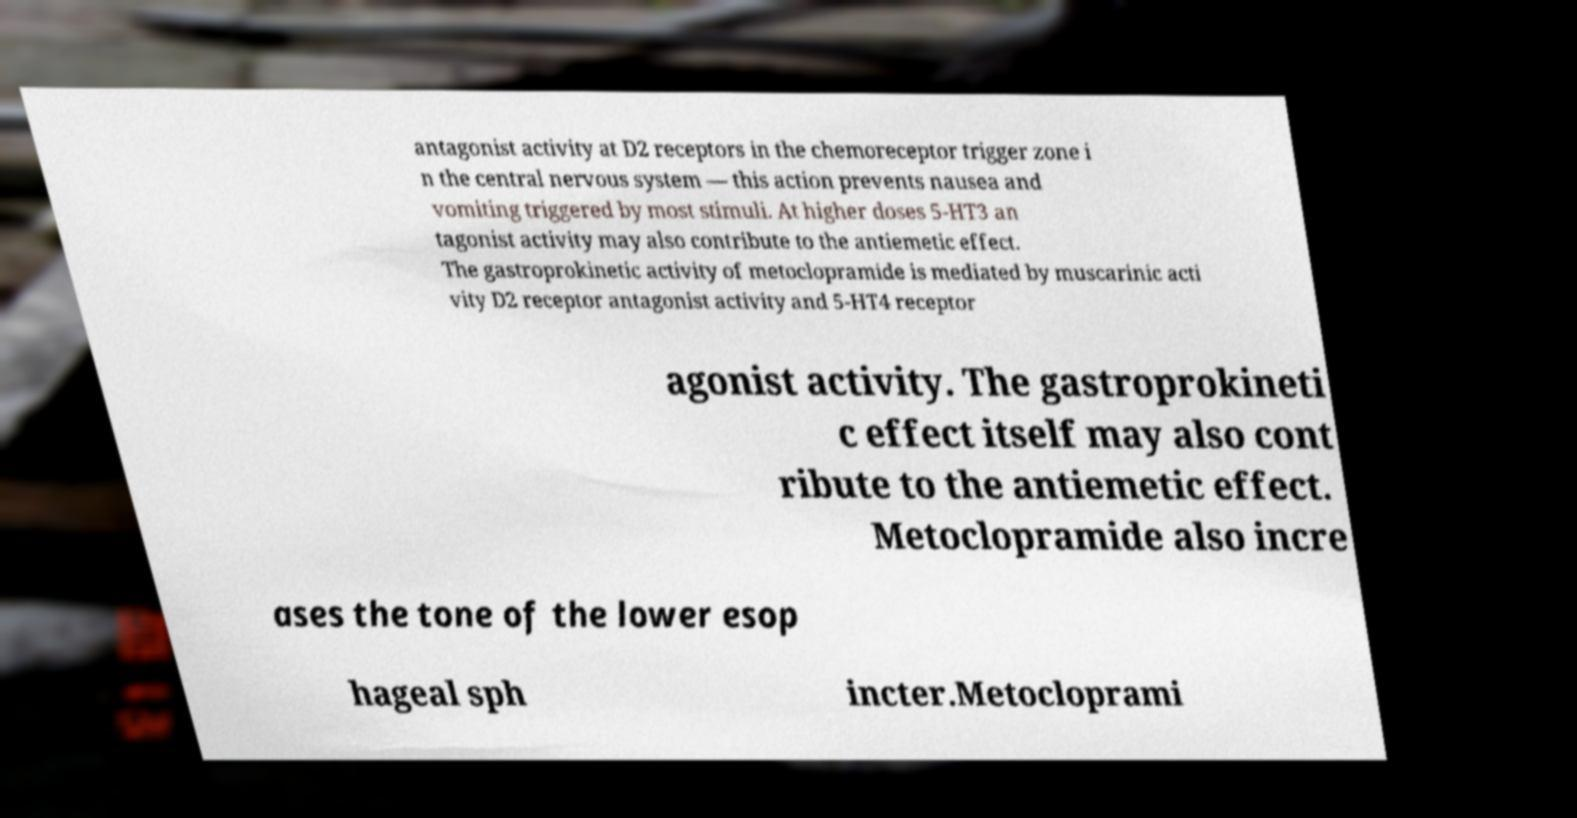Could you extract and type out the text from this image? antagonist activity at D2 receptors in the chemoreceptor trigger zone i n the central nervous system — this action prevents nausea and vomiting triggered by most stimuli. At higher doses 5-HT3 an tagonist activity may also contribute to the antiemetic effect. The gastroprokinetic activity of metoclopramide is mediated by muscarinic acti vity D2 receptor antagonist activity and 5-HT4 receptor agonist activity. The gastroprokineti c effect itself may also cont ribute to the antiemetic effect. Metoclopramide also incre ases the tone of the lower esop hageal sph incter.Metocloprami 